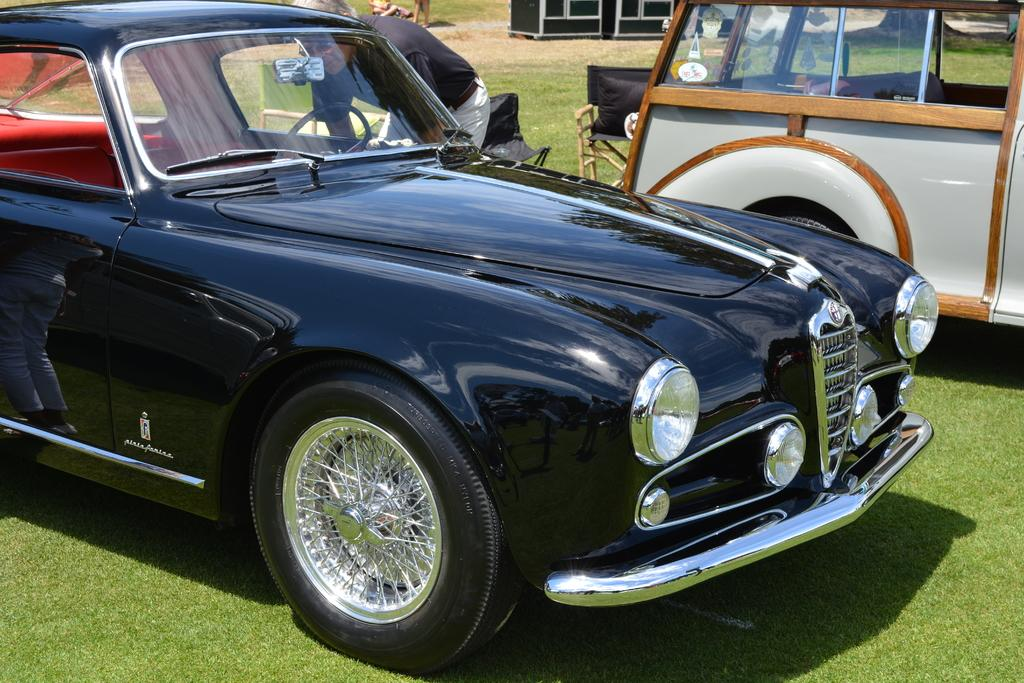What is located on the grass in the image? There are vehicles on the grass in the image. What type of furniture can be seen in the image? There are chairs in the image. Can you describe the person in the image? There is a man in the image. What can be seen in the background of the image? In the background of the image, there are legs of persons visible, and there is a black object. What type of ship can be seen in the image? There is no ship present in the image. How many beds are visible in the image? There are no beds visible in the image. 